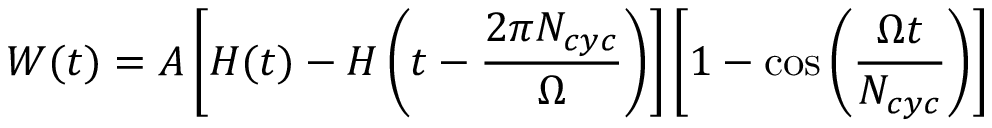<formula> <loc_0><loc_0><loc_500><loc_500>W ( t ) = A \left [ H ( t ) - H \left ( t - \frac { 2 \pi N _ { c y c } } { \Omega } \right ) \right ] \left [ 1 - \cos \left ( \frac { \Omega t } { N _ { c y c } } \right ) \right ]</formula> 